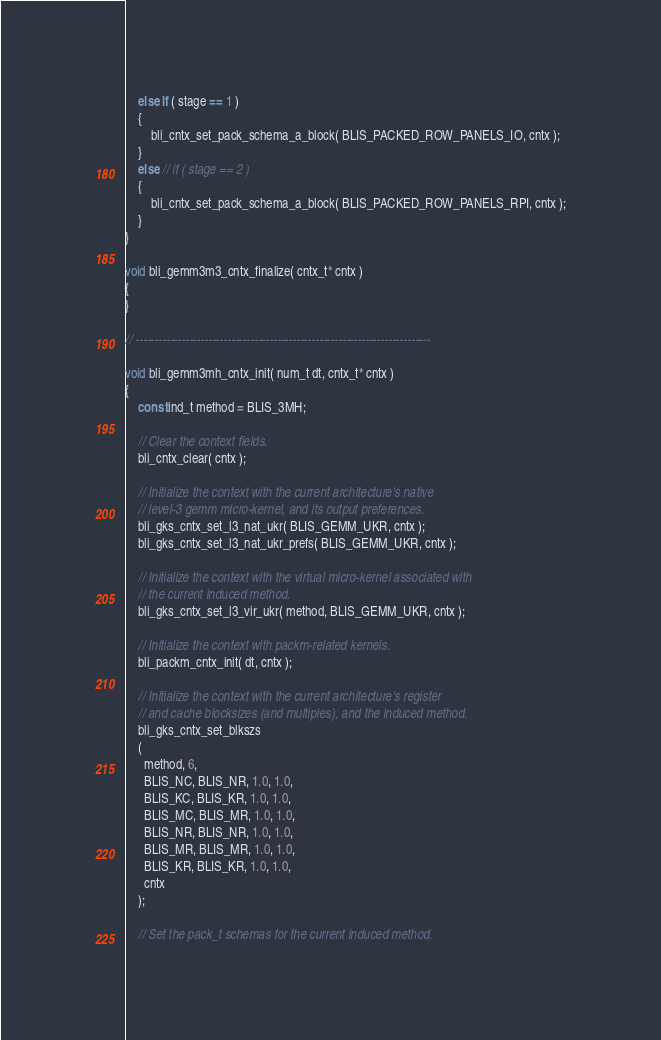<code> <loc_0><loc_0><loc_500><loc_500><_C_>	else if ( stage == 1 )
	{
		bli_cntx_set_pack_schema_a_block( BLIS_PACKED_ROW_PANELS_IO, cntx );
	}
	else // if ( stage == 2 )
	{
		bli_cntx_set_pack_schema_a_block( BLIS_PACKED_ROW_PANELS_RPI, cntx );
	}
}

void bli_gemm3m3_cntx_finalize( cntx_t* cntx )
{
}

// -----------------------------------------------------------------------------

void bli_gemm3mh_cntx_init( num_t dt, cntx_t* cntx )
{
	const ind_t method = BLIS_3MH;

	// Clear the context fields.
	bli_cntx_clear( cntx );

	// Initialize the context with the current architecture's native
	// level-3 gemm micro-kernel, and its output preferences.
	bli_gks_cntx_set_l3_nat_ukr( BLIS_GEMM_UKR, cntx );
	bli_gks_cntx_set_l3_nat_ukr_prefs( BLIS_GEMM_UKR, cntx );

	// Initialize the context with the virtual micro-kernel associated with
	// the current induced method.
	bli_gks_cntx_set_l3_vir_ukr( method, BLIS_GEMM_UKR, cntx );

	// Initialize the context with packm-related kernels.
	bli_packm_cntx_init( dt, cntx );

	// Initialize the context with the current architecture's register
	// and cache blocksizes (and multiples), and the induced method.
	bli_gks_cntx_set_blkszs
	(
	  method, 6,
	  BLIS_NC, BLIS_NR, 1.0, 1.0,
	  BLIS_KC, BLIS_KR, 1.0, 1.0,
	  BLIS_MC, BLIS_MR, 1.0, 1.0,
	  BLIS_NR, BLIS_NR, 1.0, 1.0,
	  BLIS_MR, BLIS_MR, 1.0, 1.0,
	  BLIS_KR, BLIS_KR, 1.0, 1.0,
	  cntx
	);

	// Set the pack_t schemas for the current induced method.</code> 